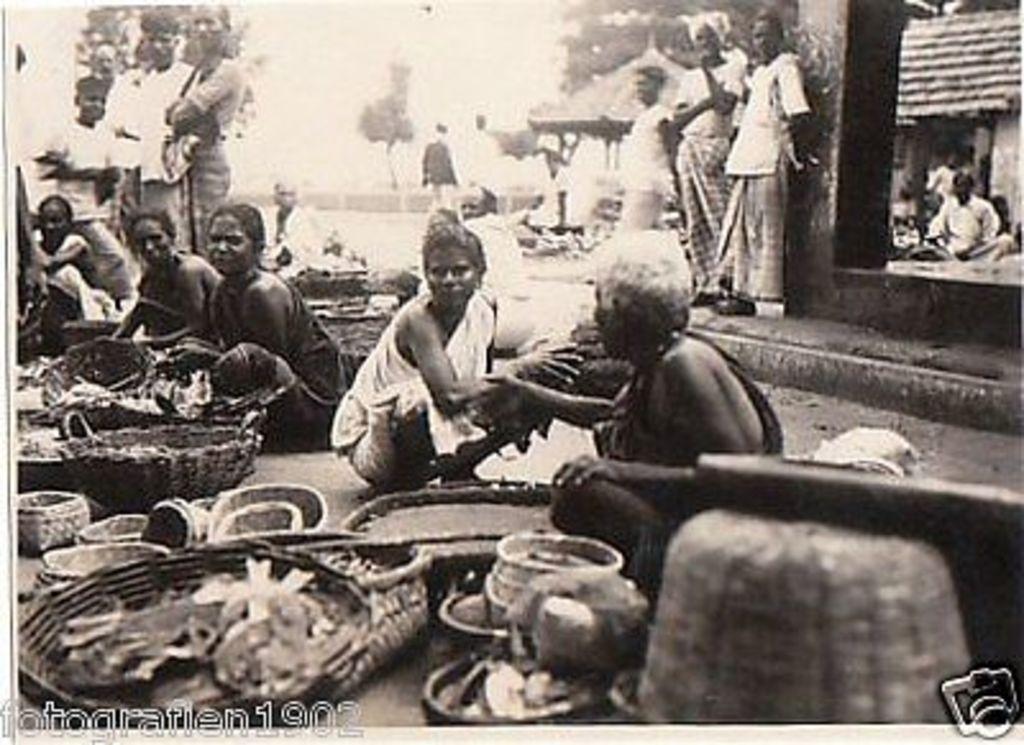Could you give a brief overview of what you see in this image? In this image there are people sitting on the road. Beside them there are few objects. On the right side of the image there are people standing in front of the building. In the background of the image there are trees. There is some text on the left side of the image. 